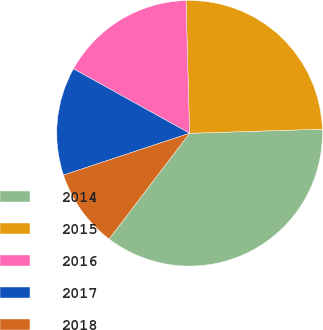<chart> <loc_0><loc_0><loc_500><loc_500><pie_chart><fcel>2014<fcel>2015<fcel>2016<fcel>2017<fcel>2018<nl><fcel>35.85%<fcel>24.93%<fcel>16.51%<fcel>13.16%<fcel>9.55%<nl></chart> 